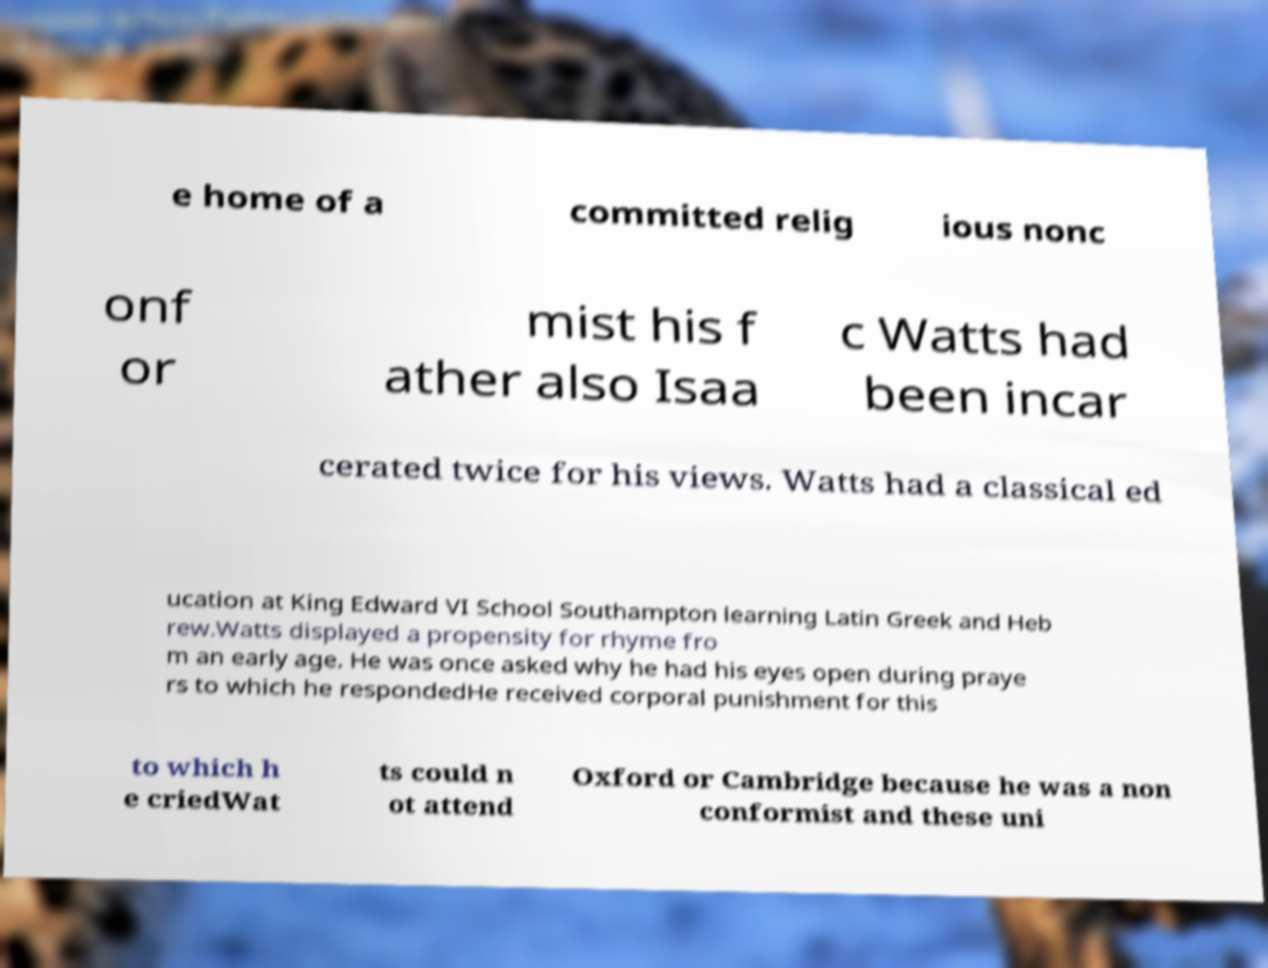Please identify and transcribe the text found in this image. e home of a committed relig ious nonc onf or mist his f ather also Isaa c Watts had been incar cerated twice for his views. Watts had a classical ed ucation at King Edward VI School Southampton learning Latin Greek and Heb rew.Watts displayed a propensity for rhyme fro m an early age. He was once asked why he had his eyes open during praye rs to which he respondedHe received corporal punishment for this to which h e criedWat ts could n ot attend Oxford or Cambridge because he was a non conformist and these uni 